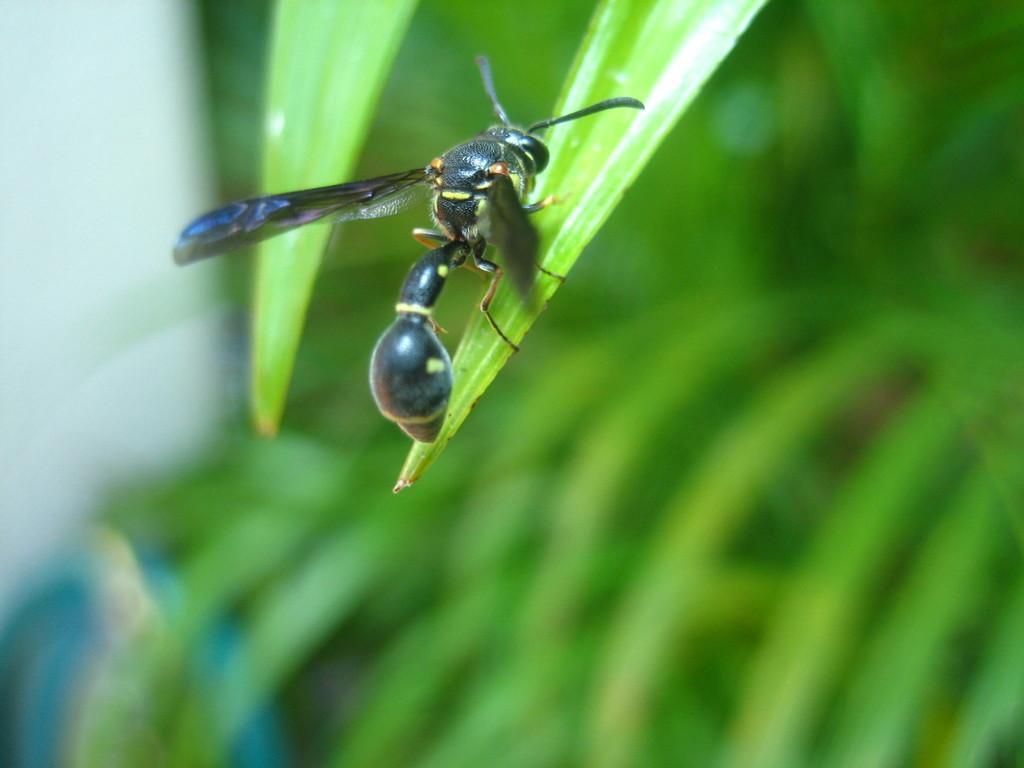In one or two sentences, can you explain what this image depicts? This is a zoomed in picture. In the center there is a fly on a leaf of a plant. In the background we can see the leaves and the background of the image is blurry. 